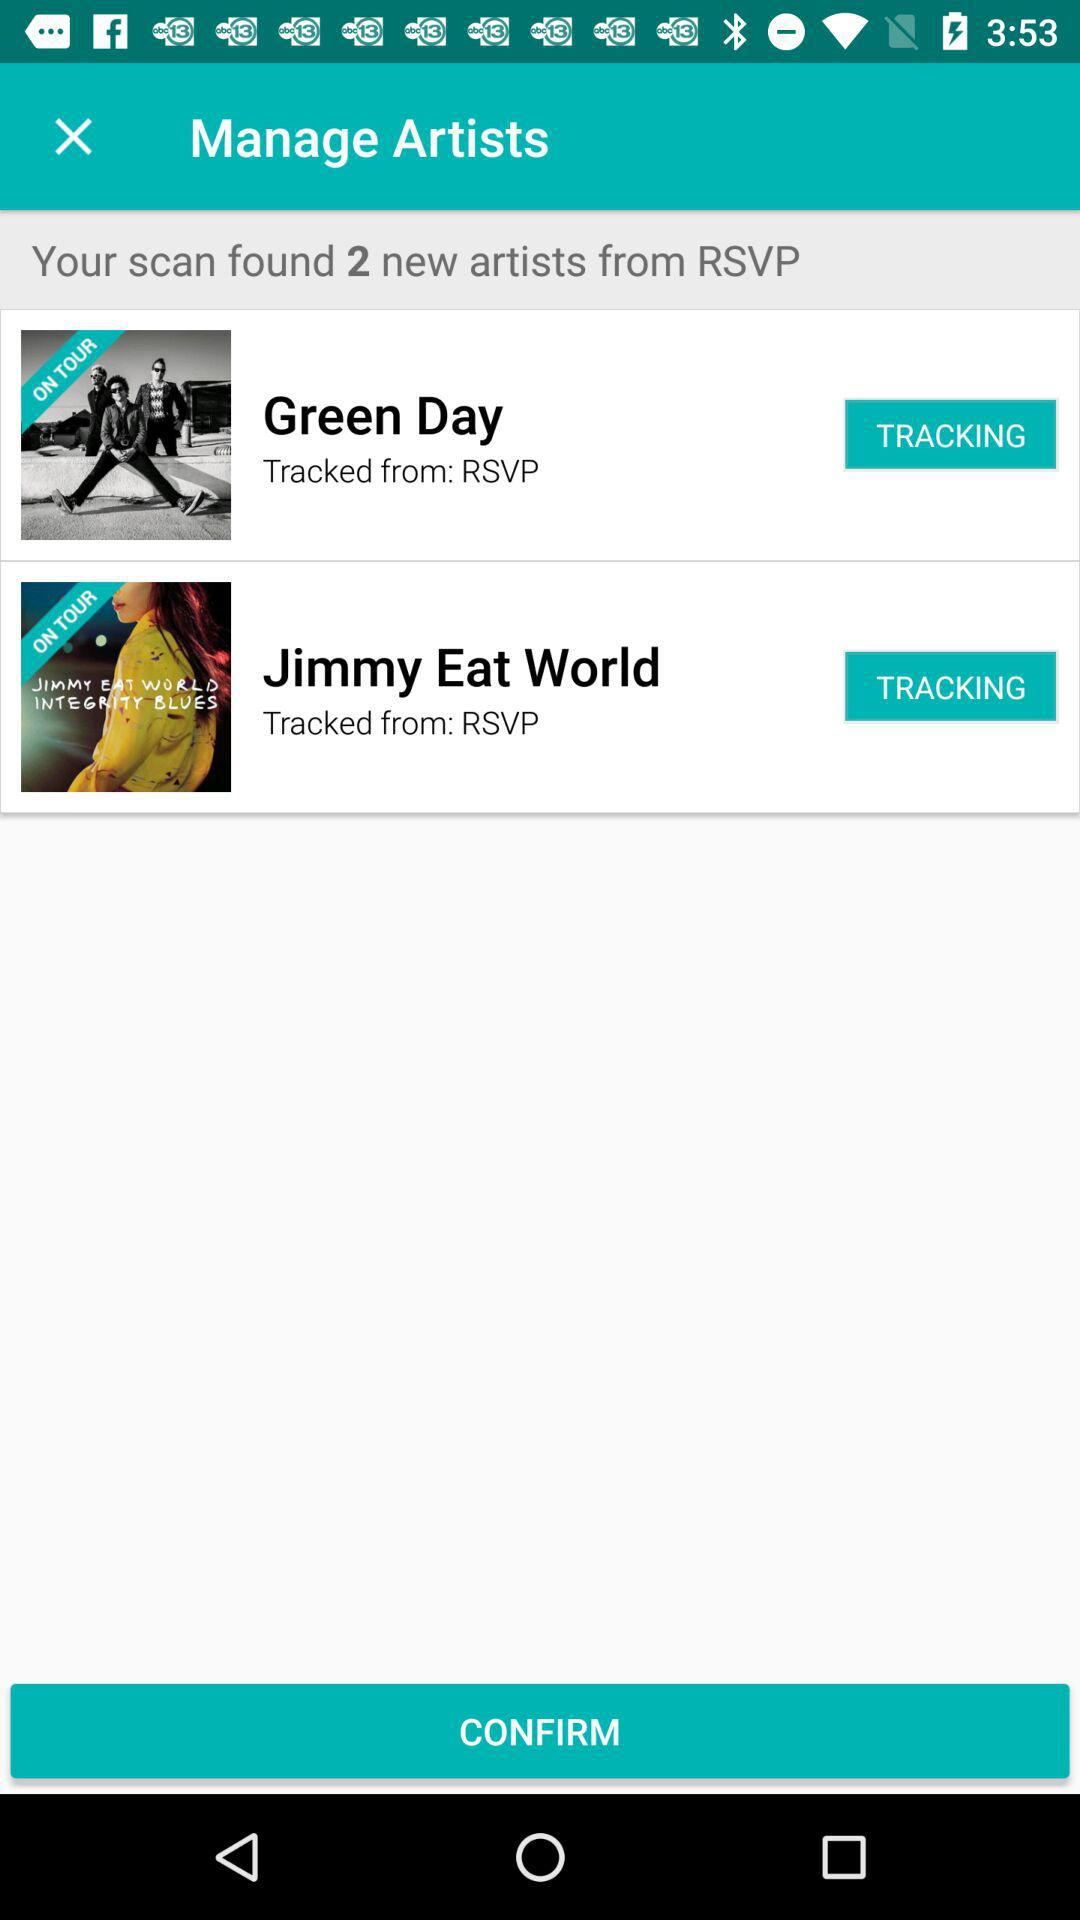How many artists were tracked from RSVP?
Answer the question using a single word or phrase. 2 